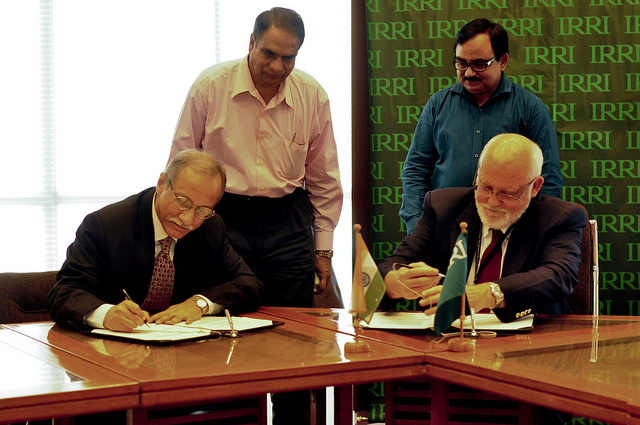Can you tell me something about the setting? The setting seems to be a professional environment, likely an office or conference room, given the formal attire of the individuals, the presence of a long conference table, and swivel chairs. Are there any distinguishing features in the room that stand out? The backdrop behind the seated men features a repeated logo, which could be the insignia of the organization or company involved in the signing event. The rest of the room is minimally decorated, reinforcing the formality of the occasion. 